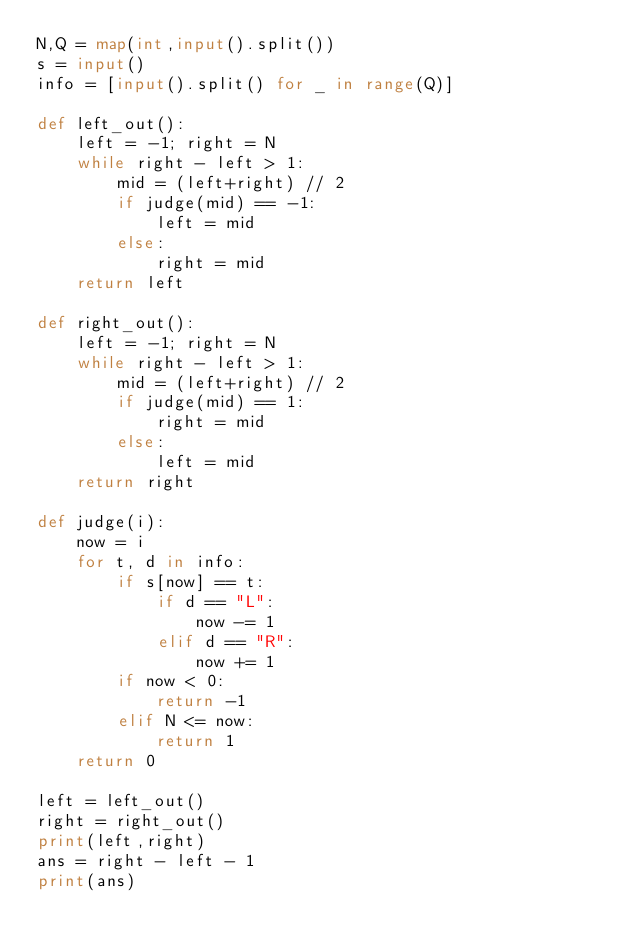<code> <loc_0><loc_0><loc_500><loc_500><_Python_>N,Q = map(int,input().split())
s = input()
info = [input().split() for _ in range(Q)]

def left_out():
    left = -1; right = N
    while right - left > 1:
        mid = (left+right) // 2
        if judge(mid) == -1:
            left = mid
        else:
            right = mid
    return left

def right_out():
    left = -1; right = N
    while right - left > 1:
        mid = (left+right) // 2
        if judge(mid) == 1:
            right = mid
        else:
            left = mid
    return right

def judge(i):
    now = i
    for t, d in info:
        if s[now] == t:
            if d == "L":
                now -= 1
            elif d == "R":
                now += 1
        if now < 0:
            return -1
        elif N <= now:
            return 1
    return 0
    
left = left_out()
right = right_out()
print(left,right)
ans = right - left - 1
print(ans)</code> 